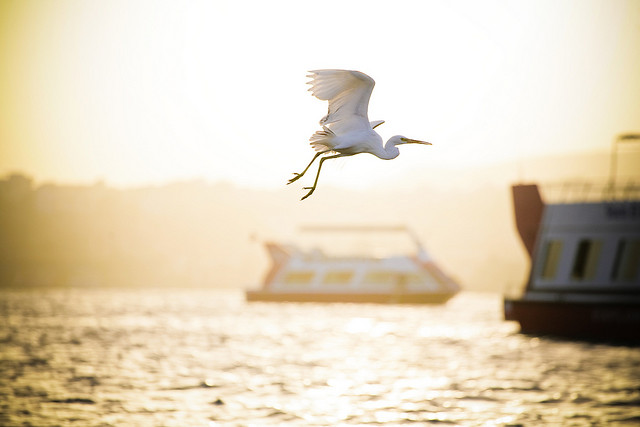Imagine this image is a scene from a movie. Describe what happens in the next scene. In the next scene, the camera zooms in on the bird, revealing a small, shimmering amulet hanging from its neck, hinting at its mysterious past. The scene transitions to the boat, where the explorers discover ancient markings on the side of the vessel, matching the symbols on the amulet. This discovery propels them into an unexpected adventure, filled with coded messages, hidden passages, and a race against time to uncover the river's long-lost treasure. 